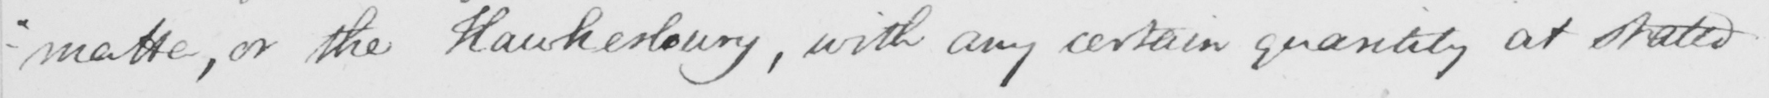Can you tell me what this handwritten text says? -"matta, or the Hawkesbury, with any certain quantity at stated 